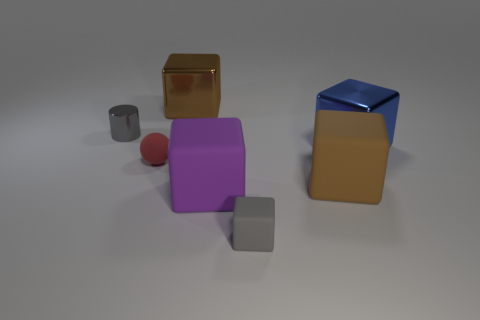Is the shape of the big brown matte thing the same as the blue metal thing?
Give a very brief answer. Yes. What is the shape of the gray rubber object that is the same size as the red ball?
Provide a short and direct response. Cube. How many small objects are either brown blocks or gray things?
Keep it short and to the point. 2. Is there a purple rubber cube that is behind the tiny gray thing right of the big cube that is behind the blue object?
Provide a short and direct response. Yes. Are there any brown rubber objects of the same size as the purple rubber block?
Provide a succinct answer. Yes. There is a gray object that is the same size as the gray block; what is it made of?
Give a very brief answer. Metal. There is a blue metal cube; is its size the same as the rubber object to the right of the tiny gray matte block?
Ensure brevity in your answer.  Yes. How many metal objects are big gray cubes or small red things?
Offer a very short reply. 0. How many small green things are the same shape as the brown metal thing?
Your answer should be very brief. 0. What material is the thing that is the same color as the small cube?
Offer a terse response. Metal. 